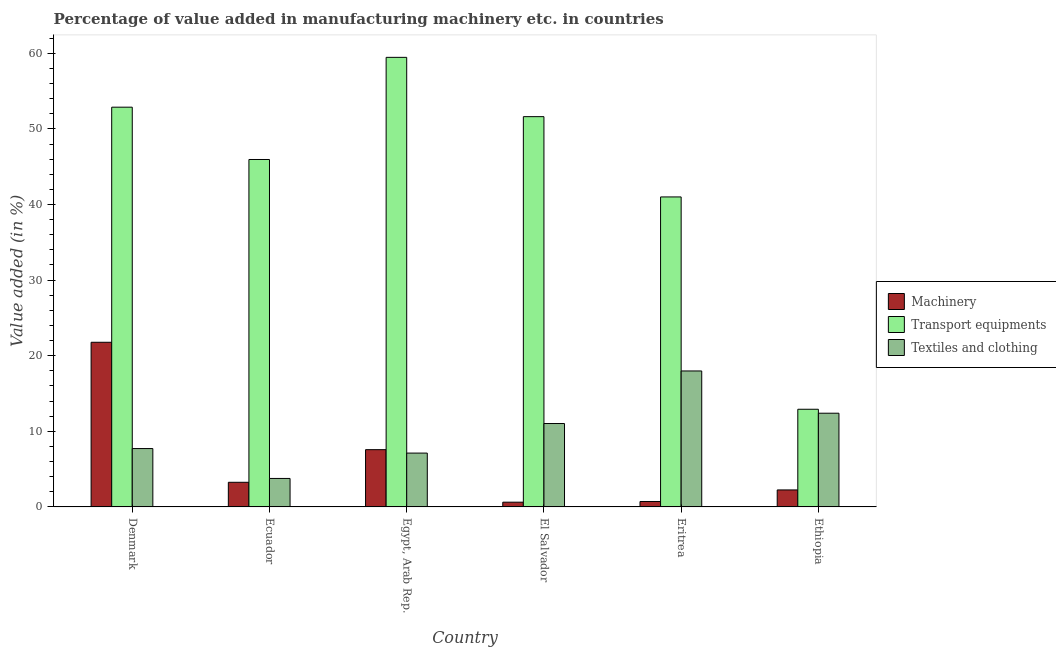How many different coloured bars are there?
Provide a succinct answer. 3. How many bars are there on the 6th tick from the left?
Keep it short and to the point. 3. What is the label of the 3rd group of bars from the left?
Your response must be concise. Egypt, Arab Rep. What is the value added in manufacturing machinery in Ecuador?
Ensure brevity in your answer.  3.26. Across all countries, what is the maximum value added in manufacturing machinery?
Make the answer very short. 21.78. Across all countries, what is the minimum value added in manufacturing textile and clothing?
Your answer should be compact. 3.77. In which country was the value added in manufacturing textile and clothing minimum?
Make the answer very short. Ecuador. What is the total value added in manufacturing textile and clothing in the graph?
Give a very brief answer. 60.02. What is the difference between the value added in manufacturing textile and clothing in Denmark and that in Ecuador?
Give a very brief answer. 3.95. What is the difference between the value added in manufacturing transport equipments in Eritrea and the value added in manufacturing machinery in Egypt, Arab Rep.?
Ensure brevity in your answer.  33.43. What is the average value added in manufacturing textile and clothing per country?
Offer a very short reply. 10. What is the difference between the value added in manufacturing machinery and value added in manufacturing transport equipments in Egypt, Arab Rep.?
Your answer should be compact. -51.89. What is the ratio of the value added in manufacturing machinery in Eritrea to that in Ethiopia?
Offer a terse response. 0.32. Is the difference between the value added in manufacturing textile and clothing in El Salvador and Eritrea greater than the difference between the value added in manufacturing machinery in El Salvador and Eritrea?
Make the answer very short. No. What is the difference between the highest and the second highest value added in manufacturing textile and clothing?
Your response must be concise. 5.59. What is the difference between the highest and the lowest value added in manufacturing transport equipments?
Keep it short and to the point. 46.54. Is the sum of the value added in manufacturing machinery in El Salvador and Eritrea greater than the maximum value added in manufacturing transport equipments across all countries?
Provide a succinct answer. No. What does the 1st bar from the left in Ethiopia represents?
Give a very brief answer. Machinery. What does the 2nd bar from the right in Denmark represents?
Offer a very short reply. Transport equipments. Is it the case that in every country, the sum of the value added in manufacturing machinery and value added in manufacturing transport equipments is greater than the value added in manufacturing textile and clothing?
Give a very brief answer. Yes. How many countries are there in the graph?
Your answer should be very brief. 6. How are the legend labels stacked?
Your answer should be compact. Vertical. What is the title of the graph?
Make the answer very short. Percentage of value added in manufacturing machinery etc. in countries. What is the label or title of the X-axis?
Make the answer very short. Country. What is the label or title of the Y-axis?
Offer a terse response. Value added (in %). What is the Value added (in %) of Machinery in Denmark?
Make the answer very short. 21.78. What is the Value added (in %) of Transport equipments in Denmark?
Your answer should be compact. 52.87. What is the Value added (in %) in Textiles and clothing in Denmark?
Give a very brief answer. 7.72. What is the Value added (in %) in Machinery in Ecuador?
Keep it short and to the point. 3.26. What is the Value added (in %) in Transport equipments in Ecuador?
Keep it short and to the point. 45.95. What is the Value added (in %) of Textiles and clothing in Ecuador?
Your response must be concise. 3.77. What is the Value added (in %) in Machinery in Egypt, Arab Rep.?
Make the answer very short. 7.57. What is the Value added (in %) in Transport equipments in Egypt, Arab Rep.?
Ensure brevity in your answer.  59.46. What is the Value added (in %) in Textiles and clothing in Egypt, Arab Rep.?
Your answer should be very brief. 7.12. What is the Value added (in %) in Machinery in El Salvador?
Give a very brief answer. 0.63. What is the Value added (in %) in Transport equipments in El Salvador?
Your answer should be compact. 51.62. What is the Value added (in %) of Textiles and clothing in El Salvador?
Your answer should be compact. 11.03. What is the Value added (in %) in Machinery in Eritrea?
Make the answer very short. 0.72. What is the Value added (in %) in Transport equipments in Eritrea?
Provide a short and direct response. 41. What is the Value added (in %) of Textiles and clothing in Eritrea?
Offer a very short reply. 17.98. What is the Value added (in %) in Machinery in Ethiopia?
Make the answer very short. 2.25. What is the Value added (in %) in Transport equipments in Ethiopia?
Provide a succinct answer. 12.92. What is the Value added (in %) in Textiles and clothing in Ethiopia?
Provide a short and direct response. 12.4. Across all countries, what is the maximum Value added (in %) in Machinery?
Your answer should be compact. 21.78. Across all countries, what is the maximum Value added (in %) of Transport equipments?
Keep it short and to the point. 59.46. Across all countries, what is the maximum Value added (in %) of Textiles and clothing?
Provide a short and direct response. 17.98. Across all countries, what is the minimum Value added (in %) of Machinery?
Offer a terse response. 0.63. Across all countries, what is the minimum Value added (in %) in Transport equipments?
Make the answer very short. 12.92. Across all countries, what is the minimum Value added (in %) of Textiles and clothing?
Your answer should be compact. 3.77. What is the total Value added (in %) in Machinery in the graph?
Your answer should be very brief. 36.21. What is the total Value added (in %) in Transport equipments in the graph?
Keep it short and to the point. 263.83. What is the total Value added (in %) in Textiles and clothing in the graph?
Your answer should be very brief. 60.02. What is the difference between the Value added (in %) in Machinery in Denmark and that in Ecuador?
Ensure brevity in your answer.  18.52. What is the difference between the Value added (in %) in Transport equipments in Denmark and that in Ecuador?
Your response must be concise. 6.92. What is the difference between the Value added (in %) in Textiles and clothing in Denmark and that in Ecuador?
Make the answer very short. 3.95. What is the difference between the Value added (in %) of Machinery in Denmark and that in Egypt, Arab Rep.?
Your answer should be very brief. 14.2. What is the difference between the Value added (in %) in Transport equipments in Denmark and that in Egypt, Arab Rep.?
Give a very brief answer. -6.59. What is the difference between the Value added (in %) of Textiles and clothing in Denmark and that in Egypt, Arab Rep.?
Offer a very short reply. 0.6. What is the difference between the Value added (in %) of Machinery in Denmark and that in El Salvador?
Offer a very short reply. 21.15. What is the difference between the Value added (in %) in Transport equipments in Denmark and that in El Salvador?
Give a very brief answer. 1.25. What is the difference between the Value added (in %) in Textiles and clothing in Denmark and that in El Salvador?
Give a very brief answer. -3.31. What is the difference between the Value added (in %) of Machinery in Denmark and that in Eritrea?
Your answer should be very brief. 21.06. What is the difference between the Value added (in %) of Transport equipments in Denmark and that in Eritrea?
Make the answer very short. 11.87. What is the difference between the Value added (in %) in Textiles and clothing in Denmark and that in Eritrea?
Offer a very short reply. -10.26. What is the difference between the Value added (in %) of Machinery in Denmark and that in Ethiopia?
Your answer should be compact. 19.53. What is the difference between the Value added (in %) in Transport equipments in Denmark and that in Ethiopia?
Make the answer very short. 39.95. What is the difference between the Value added (in %) in Textiles and clothing in Denmark and that in Ethiopia?
Make the answer very short. -4.67. What is the difference between the Value added (in %) in Machinery in Ecuador and that in Egypt, Arab Rep.?
Your response must be concise. -4.32. What is the difference between the Value added (in %) of Transport equipments in Ecuador and that in Egypt, Arab Rep.?
Offer a very short reply. -13.51. What is the difference between the Value added (in %) of Textiles and clothing in Ecuador and that in Egypt, Arab Rep.?
Provide a succinct answer. -3.35. What is the difference between the Value added (in %) of Machinery in Ecuador and that in El Salvador?
Your response must be concise. 2.63. What is the difference between the Value added (in %) in Transport equipments in Ecuador and that in El Salvador?
Make the answer very short. -5.67. What is the difference between the Value added (in %) of Textiles and clothing in Ecuador and that in El Salvador?
Offer a terse response. -7.26. What is the difference between the Value added (in %) in Machinery in Ecuador and that in Eritrea?
Your answer should be compact. 2.54. What is the difference between the Value added (in %) of Transport equipments in Ecuador and that in Eritrea?
Ensure brevity in your answer.  4.95. What is the difference between the Value added (in %) in Textiles and clothing in Ecuador and that in Eritrea?
Provide a short and direct response. -14.22. What is the difference between the Value added (in %) in Machinery in Ecuador and that in Ethiopia?
Your response must be concise. 1.01. What is the difference between the Value added (in %) of Transport equipments in Ecuador and that in Ethiopia?
Ensure brevity in your answer.  33.03. What is the difference between the Value added (in %) of Textiles and clothing in Ecuador and that in Ethiopia?
Offer a very short reply. -8.63. What is the difference between the Value added (in %) in Machinery in Egypt, Arab Rep. and that in El Salvador?
Offer a very short reply. 6.95. What is the difference between the Value added (in %) of Transport equipments in Egypt, Arab Rep. and that in El Salvador?
Keep it short and to the point. 7.84. What is the difference between the Value added (in %) in Textiles and clothing in Egypt, Arab Rep. and that in El Salvador?
Provide a succinct answer. -3.91. What is the difference between the Value added (in %) in Machinery in Egypt, Arab Rep. and that in Eritrea?
Ensure brevity in your answer.  6.85. What is the difference between the Value added (in %) of Transport equipments in Egypt, Arab Rep. and that in Eritrea?
Provide a succinct answer. 18.46. What is the difference between the Value added (in %) in Textiles and clothing in Egypt, Arab Rep. and that in Eritrea?
Offer a very short reply. -10.86. What is the difference between the Value added (in %) of Machinery in Egypt, Arab Rep. and that in Ethiopia?
Give a very brief answer. 5.33. What is the difference between the Value added (in %) in Transport equipments in Egypt, Arab Rep. and that in Ethiopia?
Make the answer very short. 46.54. What is the difference between the Value added (in %) in Textiles and clothing in Egypt, Arab Rep. and that in Ethiopia?
Your answer should be compact. -5.28. What is the difference between the Value added (in %) in Machinery in El Salvador and that in Eritrea?
Your answer should be very brief. -0.09. What is the difference between the Value added (in %) of Transport equipments in El Salvador and that in Eritrea?
Provide a short and direct response. 10.62. What is the difference between the Value added (in %) in Textiles and clothing in El Salvador and that in Eritrea?
Offer a very short reply. -6.95. What is the difference between the Value added (in %) of Machinery in El Salvador and that in Ethiopia?
Your answer should be very brief. -1.62. What is the difference between the Value added (in %) in Transport equipments in El Salvador and that in Ethiopia?
Provide a succinct answer. 38.7. What is the difference between the Value added (in %) in Textiles and clothing in El Salvador and that in Ethiopia?
Provide a succinct answer. -1.36. What is the difference between the Value added (in %) of Machinery in Eritrea and that in Ethiopia?
Provide a succinct answer. -1.53. What is the difference between the Value added (in %) in Transport equipments in Eritrea and that in Ethiopia?
Your answer should be compact. 28.08. What is the difference between the Value added (in %) of Textiles and clothing in Eritrea and that in Ethiopia?
Your answer should be very brief. 5.59. What is the difference between the Value added (in %) in Machinery in Denmark and the Value added (in %) in Transport equipments in Ecuador?
Provide a succinct answer. -24.17. What is the difference between the Value added (in %) of Machinery in Denmark and the Value added (in %) of Textiles and clothing in Ecuador?
Keep it short and to the point. 18.01. What is the difference between the Value added (in %) of Transport equipments in Denmark and the Value added (in %) of Textiles and clothing in Ecuador?
Provide a short and direct response. 49.11. What is the difference between the Value added (in %) of Machinery in Denmark and the Value added (in %) of Transport equipments in Egypt, Arab Rep.?
Your response must be concise. -37.69. What is the difference between the Value added (in %) of Machinery in Denmark and the Value added (in %) of Textiles and clothing in Egypt, Arab Rep.?
Provide a succinct answer. 14.66. What is the difference between the Value added (in %) in Transport equipments in Denmark and the Value added (in %) in Textiles and clothing in Egypt, Arab Rep.?
Provide a short and direct response. 45.75. What is the difference between the Value added (in %) of Machinery in Denmark and the Value added (in %) of Transport equipments in El Salvador?
Offer a very short reply. -29.84. What is the difference between the Value added (in %) in Machinery in Denmark and the Value added (in %) in Textiles and clothing in El Salvador?
Make the answer very short. 10.75. What is the difference between the Value added (in %) in Transport equipments in Denmark and the Value added (in %) in Textiles and clothing in El Salvador?
Keep it short and to the point. 41.84. What is the difference between the Value added (in %) in Machinery in Denmark and the Value added (in %) in Transport equipments in Eritrea?
Your answer should be compact. -19.22. What is the difference between the Value added (in %) in Machinery in Denmark and the Value added (in %) in Textiles and clothing in Eritrea?
Provide a short and direct response. 3.79. What is the difference between the Value added (in %) in Transport equipments in Denmark and the Value added (in %) in Textiles and clothing in Eritrea?
Make the answer very short. 34.89. What is the difference between the Value added (in %) in Machinery in Denmark and the Value added (in %) in Transport equipments in Ethiopia?
Your answer should be compact. 8.86. What is the difference between the Value added (in %) in Machinery in Denmark and the Value added (in %) in Textiles and clothing in Ethiopia?
Keep it short and to the point. 9.38. What is the difference between the Value added (in %) of Transport equipments in Denmark and the Value added (in %) of Textiles and clothing in Ethiopia?
Your answer should be very brief. 40.48. What is the difference between the Value added (in %) in Machinery in Ecuador and the Value added (in %) in Transport equipments in Egypt, Arab Rep.?
Keep it short and to the point. -56.2. What is the difference between the Value added (in %) in Machinery in Ecuador and the Value added (in %) in Textiles and clothing in Egypt, Arab Rep.?
Make the answer very short. -3.86. What is the difference between the Value added (in %) of Transport equipments in Ecuador and the Value added (in %) of Textiles and clothing in Egypt, Arab Rep.?
Offer a very short reply. 38.83. What is the difference between the Value added (in %) in Machinery in Ecuador and the Value added (in %) in Transport equipments in El Salvador?
Offer a terse response. -48.36. What is the difference between the Value added (in %) in Machinery in Ecuador and the Value added (in %) in Textiles and clothing in El Salvador?
Keep it short and to the point. -7.77. What is the difference between the Value added (in %) of Transport equipments in Ecuador and the Value added (in %) of Textiles and clothing in El Salvador?
Keep it short and to the point. 34.92. What is the difference between the Value added (in %) in Machinery in Ecuador and the Value added (in %) in Transport equipments in Eritrea?
Give a very brief answer. -37.74. What is the difference between the Value added (in %) of Machinery in Ecuador and the Value added (in %) of Textiles and clothing in Eritrea?
Provide a short and direct response. -14.72. What is the difference between the Value added (in %) in Transport equipments in Ecuador and the Value added (in %) in Textiles and clothing in Eritrea?
Your answer should be compact. 27.97. What is the difference between the Value added (in %) of Machinery in Ecuador and the Value added (in %) of Transport equipments in Ethiopia?
Offer a terse response. -9.66. What is the difference between the Value added (in %) of Machinery in Ecuador and the Value added (in %) of Textiles and clothing in Ethiopia?
Offer a terse response. -9.14. What is the difference between the Value added (in %) of Transport equipments in Ecuador and the Value added (in %) of Textiles and clothing in Ethiopia?
Keep it short and to the point. 33.56. What is the difference between the Value added (in %) in Machinery in Egypt, Arab Rep. and the Value added (in %) in Transport equipments in El Salvador?
Keep it short and to the point. -44.05. What is the difference between the Value added (in %) of Machinery in Egypt, Arab Rep. and the Value added (in %) of Textiles and clothing in El Salvador?
Your answer should be compact. -3.46. What is the difference between the Value added (in %) in Transport equipments in Egypt, Arab Rep. and the Value added (in %) in Textiles and clothing in El Salvador?
Provide a succinct answer. 48.43. What is the difference between the Value added (in %) of Machinery in Egypt, Arab Rep. and the Value added (in %) of Transport equipments in Eritrea?
Offer a terse response. -33.43. What is the difference between the Value added (in %) in Machinery in Egypt, Arab Rep. and the Value added (in %) in Textiles and clothing in Eritrea?
Make the answer very short. -10.41. What is the difference between the Value added (in %) in Transport equipments in Egypt, Arab Rep. and the Value added (in %) in Textiles and clothing in Eritrea?
Your answer should be compact. 41.48. What is the difference between the Value added (in %) in Machinery in Egypt, Arab Rep. and the Value added (in %) in Transport equipments in Ethiopia?
Offer a terse response. -5.34. What is the difference between the Value added (in %) of Machinery in Egypt, Arab Rep. and the Value added (in %) of Textiles and clothing in Ethiopia?
Give a very brief answer. -4.82. What is the difference between the Value added (in %) in Transport equipments in Egypt, Arab Rep. and the Value added (in %) in Textiles and clothing in Ethiopia?
Keep it short and to the point. 47.07. What is the difference between the Value added (in %) of Machinery in El Salvador and the Value added (in %) of Transport equipments in Eritrea?
Offer a very short reply. -40.38. What is the difference between the Value added (in %) of Machinery in El Salvador and the Value added (in %) of Textiles and clothing in Eritrea?
Your response must be concise. -17.36. What is the difference between the Value added (in %) in Transport equipments in El Salvador and the Value added (in %) in Textiles and clothing in Eritrea?
Make the answer very short. 33.64. What is the difference between the Value added (in %) of Machinery in El Salvador and the Value added (in %) of Transport equipments in Ethiopia?
Give a very brief answer. -12.29. What is the difference between the Value added (in %) of Machinery in El Salvador and the Value added (in %) of Textiles and clothing in Ethiopia?
Offer a terse response. -11.77. What is the difference between the Value added (in %) of Transport equipments in El Salvador and the Value added (in %) of Textiles and clothing in Ethiopia?
Make the answer very short. 39.23. What is the difference between the Value added (in %) in Machinery in Eritrea and the Value added (in %) in Transport equipments in Ethiopia?
Offer a terse response. -12.2. What is the difference between the Value added (in %) in Machinery in Eritrea and the Value added (in %) in Textiles and clothing in Ethiopia?
Make the answer very short. -11.68. What is the difference between the Value added (in %) of Transport equipments in Eritrea and the Value added (in %) of Textiles and clothing in Ethiopia?
Offer a very short reply. 28.61. What is the average Value added (in %) in Machinery per country?
Keep it short and to the point. 6.03. What is the average Value added (in %) of Transport equipments per country?
Keep it short and to the point. 43.97. What is the average Value added (in %) of Textiles and clothing per country?
Make the answer very short. 10. What is the difference between the Value added (in %) in Machinery and Value added (in %) in Transport equipments in Denmark?
Your answer should be very brief. -31.09. What is the difference between the Value added (in %) of Machinery and Value added (in %) of Textiles and clothing in Denmark?
Ensure brevity in your answer.  14.06. What is the difference between the Value added (in %) in Transport equipments and Value added (in %) in Textiles and clothing in Denmark?
Provide a short and direct response. 45.15. What is the difference between the Value added (in %) of Machinery and Value added (in %) of Transport equipments in Ecuador?
Offer a terse response. -42.69. What is the difference between the Value added (in %) of Machinery and Value added (in %) of Textiles and clothing in Ecuador?
Provide a short and direct response. -0.51. What is the difference between the Value added (in %) in Transport equipments and Value added (in %) in Textiles and clothing in Ecuador?
Provide a short and direct response. 42.19. What is the difference between the Value added (in %) of Machinery and Value added (in %) of Transport equipments in Egypt, Arab Rep.?
Provide a short and direct response. -51.89. What is the difference between the Value added (in %) of Machinery and Value added (in %) of Textiles and clothing in Egypt, Arab Rep.?
Your response must be concise. 0.45. What is the difference between the Value added (in %) in Transport equipments and Value added (in %) in Textiles and clothing in Egypt, Arab Rep.?
Your answer should be compact. 52.34. What is the difference between the Value added (in %) of Machinery and Value added (in %) of Transport equipments in El Salvador?
Provide a succinct answer. -50.99. What is the difference between the Value added (in %) of Machinery and Value added (in %) of Textiles and clothing in El Salvador?
Offer a very short reply. -10.4. What is the difference between the Value added (in %) of Transport equipments and Value added (in %) of Textiles and clothing in El Salvador?
Provide a succinct answer. 40.59. What is the difference between the Value added (in %) of Machinery and Value added (in %) of Transport equipments in Eritrea?
Your answer should be compact. -40.28. What is the difference between the Value added (in %) of Machinery and Value added (in %) of Textiles and clothing in Eritrea?
Provide a short and direct response. -17.26. What is the difference between the Value added (in %) in Transport equipments and Value added (in %) in Textiles and clothing in Eritrea?
Keep it short and to the point. 23.02. What is the difference between the Value added (in %) of Machinery and Value added (in %) of Transport equipments in Ethiopia?
Provide a succinct answer. -10.67. What is the difference between the Value added (in %) of Machinery and Value added (in %) of Textiles and clothing in Ethiopia?
Your response must be concise. -10.15. What is the difference between the Value added (in %) in Transport equipments and Value added (in %) in Textiles and clothing in Ethiopia?
Ensure brevity in your answer.  0.52. What is the ratio of the Value added (in %) of Machinery in Denmark to that in Ecuador?
Your answer should be compact. 6.68. What is the ratio of the Value added (in %) in Transport equipments in Denmark to that in Ecuador?
Provide a short and direct response. 1.15. What is the ratio of the Value added (in %) of Textiles and clothing in Denmark to that in Ecuador?
Provide a succinct answer. 2.05. What is the ratio of the Value added (in %) of Machinery in Denmark to that in Egypt, Arab Rep.?
Ensure brevity in your answer.  2.88. What is the ratio of the Value added (in %) of Transport equipments in Denmark to that in Egypt, Arab Rep.?
Make the answer very short. 0.89. What is the ratio of the Value added (in %) of Textiles and clothing in Denmark to that in Egypt, Arab Rep.?
Keep it short and to the point. 1.08. What is the ratio of the Value added (in %) of Machinery in Denmark to that in El Salvador?
Offer a very short reply. 34.7. What is the ratio of the Value added (in %) in Transport equipments in Denmark to that in El Salvador?
Offer a terse response. 1.02. What is the ratio of the Value added (in %) in Machinery in Denmark to that in Eritrea?
Give a very brief answer. 30.25. What is the ratio of the Value added (in %) in Transport equipments in Denmark to that in Eritrea?
Give a very brief answer. 1.29. What is the ratio of the Value added (in %) in Textiles and clothing in Denmark to that in Eritrea?
Give a very brief answer. 0.43. What is the ratio of the Value added (in %) in Machinery in Denmark to that in Ethiopia?
Your answer should be compact. 9.69. What is the ratio of the Value added (in %) in Transport equipments in Denmark to that in Ethiopia?
Your response must be concise. 4.09. What is the ratio of the Value added (in %) of Textiles and clothing in Denmark to that in Ethiopia?
Your answer should be very brief. 0.62. What is the ratio of the Value added (in %) of Machinery in Ecuador to that in Egypt, Arab Rep.?
Offer a terse response. 0.43. What is the ratio of the Value added (in %) of Transport equipments in Ecuador to that in Egypt, Arab Rep.?
Make the answer very short. 0.77. What is the ratio of the Value added (in %) of Textiles and clothing in Ecuador to that in Egypt, Arab Rep.?
Offer a very short reply. 0.53. What is the ratio of the Value added (in %) in Machinery in Ecuador to that in El Salvador?
Your response must be concise. 5.19. What is the ratio of the Value added (in %) of Transport equipments in Ecuador to that in El Salvador?
Your answer should be compact. 0.89. What is the ratio of the Value added (in %) of Textiles and clothing in Ecuador to that in El Salvador?
Provide a short and direct response. 0.34. What is the ratio of the Value added (in %) in Machinery in Ecuador to that in Eritrea?
Your response must be concise. 4.53. What is the ratio of the Value added (in %) of Transport equipments in Ecuador to that in Eritrea?
Give a very brief answer. 1.12. What is the ratio of the Value added (in %) of Textiles and clothing in Ecuador to that in Eritrea?
Offer a terse response. 0.21. What is the ratio of the Value added (in %) in Machinery in Ecuador to that in Ethiopia?
Keep it short and to the point. 1.45. What is the ratio of the Value added (in %) in Transport equipments in Ecuador to that in Ethiopia?
Your response must be concise. 3.56. What is the ratio of the Value added (in %) of Textiles and clothing in Ecuador to that in Ethiopia?
Your answer should be very brief. 0.3. What is the ratio of the Value added (in %) in Machinery in Egypt, Arab Rep. to that in El Salvador?
Offer a terse response. 12.07. What is the ratio of the Value added (in %) of Transport equipments in Egypt, Arab Rep. to that in El Salvador?
Ensure brevity in your answer.  1.15. What is the ratio of the Value added (in %) of Textiles and clothing in Egypt, Arab Rep. to that in El Salvador?
Give a very brief answer. 0.65. What is the ratio of the Value added (in %) of Machinery in Egypt, Arab Rep. to that in Eritrea?
Keep it short and to the point. 10.52. What is the ratio of the Value added (in %) in Transport equipments in Egypt, Arab Rep. to that in Eritrea?
Offer a very short reply. 1.45. What is the ratio of the Value added (in %) in Textiles and clothing in Egypt, Arab Rep. to that in Eritrea?
Offer a terse response. 0.4. What is the ratio of the Value added (in %) in Machinery in Egypt, Arab Rep. to that in Ethiopia?
Offer a terse response. 3.37. What is the ratio of the Value added (in %) of Transport equipments in Egypt, Arab Rep. to that in Ethiopia?
Ensure brevity in your answer.  4.6. What is the ratio of the Value added (in %) of Textiles and clothing in Egypt, Arab Rep. to that in Ethiopia?
Your answer should be very brief. 0.57. What is the ratio of the Value added (in %) in Machinery in El Salvador to that in Eritrea?
Your answer should be compact. 0.87. What is the ratio of the Value added (in %) of Transport equipments in El Salvador to that in Eritrea?
Make the answer very short. 1.26. What is the ratio of the Value added (in %) of Textiles and clothing in El Salvador to that in Eritrea?
Keep it short and to the point. 0.61. What is the ratio of the Value added (in %) of Machinery in El Salvador to that in Ethiopia?
Offer a very short reply. 0.28. What is the ratio of the Value added (in %) in Transport equipments in El Salvador to that in Ethiopia?
Your answer should be very brief. 4. What is the ratio of the Value added (in %) of Textiles and clothing in El Salvador to that in Ethiopia?
Provide a succinct answer. 0.89. What is the ratio of the Value added (in %) in Machinery in Eritrea to that in Ethiopia?
Ensure brevity in your answer.  0.32. What is the ratio of the Value added (in %) in Transport equipments in Eritrea to that in Ethiopia?
Offer a terse response. 3.17. What is the ratio of the Value added (in %) of Textiles and clothing in Eritrea to that in Ethiopia?
Offer a very short reply. 1.45. What is the difference between the highest and the second highest Value added (in %) of Machinery?
Provide a short and direct response. 14.2. What is the difference between the highest and the second highest Value added (in %) in Transport equipments?
Provide a short and direct response. 6.59. What is the difference between the highest and the second highest Value added (in %) of Textiles and clothing?
Your answer should be compact. 5.59. What is the difference between the highest and the lowest Value added (in %) in Machinery?
Give a very brief answer. 21.15. What is the difference between the highest and the lowest Value added (in %) of Transport equipments?
Provide a succinct answer. 46.54. What is the difference between the highest and the lowest Value added (in %) in Textiles and clothing?
Give a very brief answer. 14.22. 